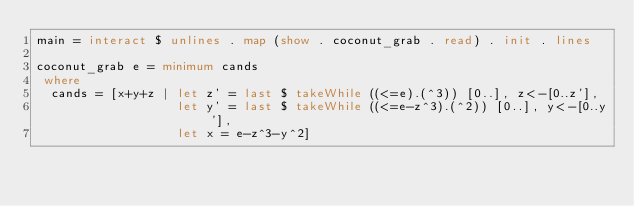<code> <loc_0><loc_0><loc_500><loc_500><_Haskell_>main = interact $ unlines . map (show . coconut_grab . read) . init . lines
 
coconut_grab e = minimum cands
 where
  cands = [x+y+z | let z' = last $ takeWhile ((<=e).(^3)) [0..], z<-[0..z'],
                   let y' = last $ takeWhile ((<=e-z^3).(^2)) [0..], y<-[0..y'],
                   let x = e-z^3-y^2]</code> 